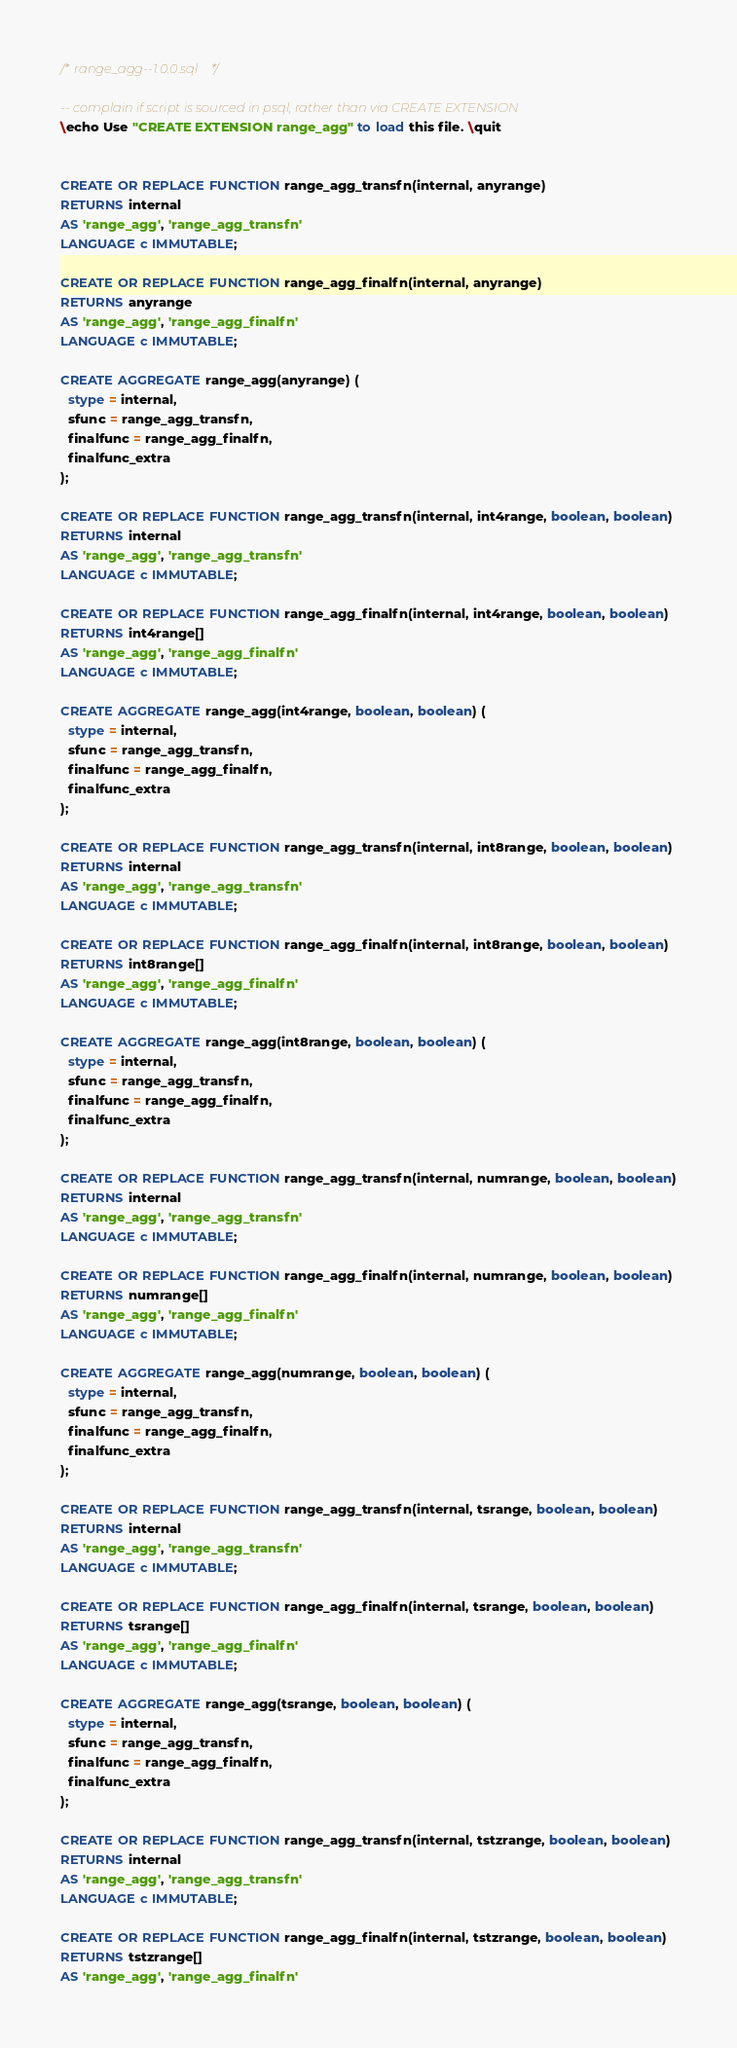<code> <loc_0><loc_0><loc_500><loc_500><_SQL_>/* range_agg--1.0.0.sql */

-- complain if script is sourced in psql, rather than via CREATE EXTENSION
\echo Use "CREATE EXTENSION range_agg" to load this file. \quit


CREATE OR REPLACE FUNCTION range_agg_transfn(internal, anyrange)
RETURNS internal
AS 'range_agg', 'range_agg_transfn'
LANGUAGE c IMMUTABLE;

CREATE OR REPLACE FUNCTION range_agg_finalfn(internal, anyrange)
RETURNS anyrange
AS 'range_agg', 'range_agg_finalfn'
LANGUAGE c IMMUTABLE;

CREATE AGGREGATE range_agg(anyrange) (
  stype = internal,
  sfunc = range_agg_transfn,
  finalfunc = range_agg_finalfn,
  finalfunc_extra
);

CREATE OR REPLACE FUNCTION range_agg_transfn(internal, int4range, boolean, boolean)
RETURNS internal
AS 'range_agg', 'range_agg_transfn'
LANGUAGE c IMMUTABLE;

CREATE OR REPLACE FUNCTION range_agg_finalfn(internal, int4range, boolean, boolean)
RETURNS int4range[]
AS 'range_agg', 'range_agg_finalfn'
LANGUAGE c IMMUTABLE;

CREATE AGGREGATE range_agg(int4range, boolean, boolean) (
  stype = internal,
  sfunc = range_agg_transfn,
  finalfunc = range_agg_finalfn,
  finalfunc_extra
);

CREATE OR REPLACE FUNCTION range_agg_transfn(internal, int8range, boolean, boolean)
RETURNS internal
AS 'range_agg', 'range_agg_transfn'
LANGUAGE c IMMUTABLE;

CREATE OR REPLACE FUNCTION range_agg_finalfn(internal, int8range, boolean, boolean)
RETURNS int8range[]
AS 'range_agg', 'range_agg_finalfn'
LANGUAGE c IMMUTABLE;

CREATE AGGREGATE range_agg(int8range, boolean, boolean) (
  stype = internal,
  sfunc = range_agg_transfn,
  finalfunc = range_agg_finalfn,
  finalfunc_extra
);

CREATE OR REPLACE FUNCTION range_agg_transfn(internal, numrange, boolean, boolean)
RETURNS internal
AS 'range_agg', 'range_agg_transfn'
LANGUAGE c IMMUTABLE;

CREATE OR REPLACE FUNCTION range_agg_finalfn(internal, numrange, boolean, boolean)
RETURNS numrange[]
AS 'range_agg', 'range_agg_finalfn'
LANGUAGE c IMMUTABLE;

CREATE AGGREGATE range_agg(numrange, boolean, boolean) (
  stype = internal,
  sfunc = range_agg_transfn,
  finalfunc = range_agg_finalfn,
  finalfunc_extra
);

CREATE OR REPLACE FUNCTION range_agg_transfn(internal, tsrange, boolean, boolean)
RETURNS internal
AS 'range_agg', 'range_agg_transfn'
LANGUAGE c IMMUTABLE;

CREATE OR REPLACE FUNCTION range_agg_finalfn(internal, tsrange, boolean, boolean)
RETURNS tsrange[]
AS 'range_agg', 'range_agg_finalfn'
LANGUAGE c IMMUTABLE;

CREATE AGGREGATE range_agg(tsrange, boolean, boolean) (
  stype = internal,
  sfunc = range_agg_transfn,
  finalfunc = range_agg_finalfn,
  finalfunc_extra
);

CREATE OR REPLACE FUNCTION range_agg_transfn(internal, tstzrange, boolean, boolean)
RETURNS internal
AS 'range_agg', 'range_agg_transfn'
LANGUAGE c IMMUTABLE;

CREATE OR REPLACE FUNCTION range_agg_finalfn(internal, tstzrange, boolean, boolean)
RETURNS tstzrange[]
AS 'range_agg', 'range_agg_finalfn'</code> 